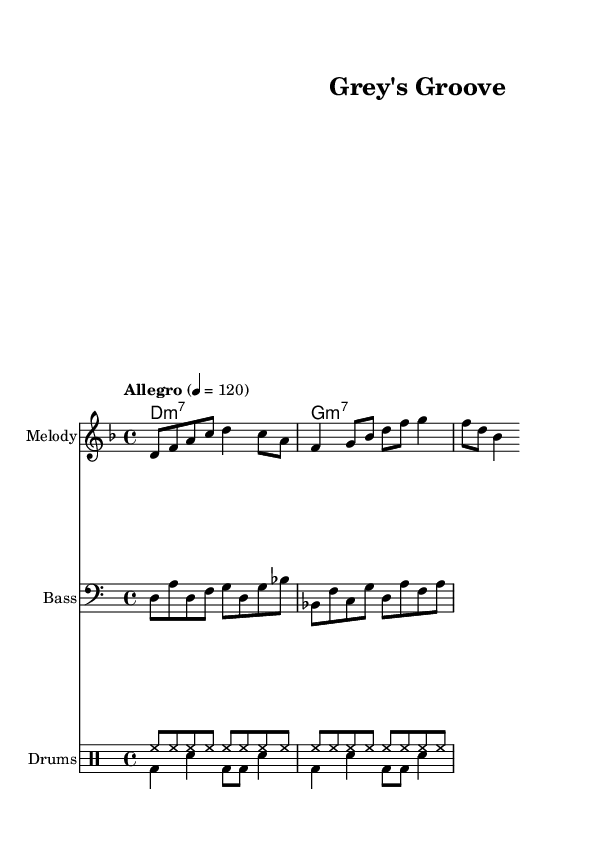What is the key signature of this music? The key signature is D minor, which consists of one flat (B flat). This can be identified from the key signature indicated at the beginning of the score.
Answer: D minor What is the time signature of this music? The time signature is 4/4, which means there are four beats per measure and the quarter note gets one beat. This is located at the beginning of the score.
Answer: 4/4 What is the tempo marking in this piece? The tempo marking is "Allegro" with a metronome marking of 120 beats per minute. This can be found at the beginning of the score.
Answer: Allegro 4 = 120 How many measures are in the melody section? The melody section consists of two measures. This can be counted by looking at the vertical bar lines that separate the measures.
Answer: 2 What type of chords are used in the harmonies? The harmonies are minor seventh chords, indicated by the notation "m7" that follows the root of the chord. This indicates the specific sound quality of the chords used.
Answer: Minor seventh How is the rhythm of the bass line characterized? The bass line features a syncopated rhythm with off-beat accents, evident in the alternating eighth and quarter notes that create a groove typical of funk music, noticeable in the bass staff.
Answer: Syncopated What is the function of the drums in this piece? The drums provide a consistent upbeat rhythm, which is typical for funk music, featuring both hi-hat and bass drum patterns that drive the energetic feel of the piece. This can be seen in the drumming notation.
Answer: Upbeat rhythm 